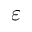<formula> <loc_0><loc_0><loc_500><loc_500>\varepsilon</formula> 